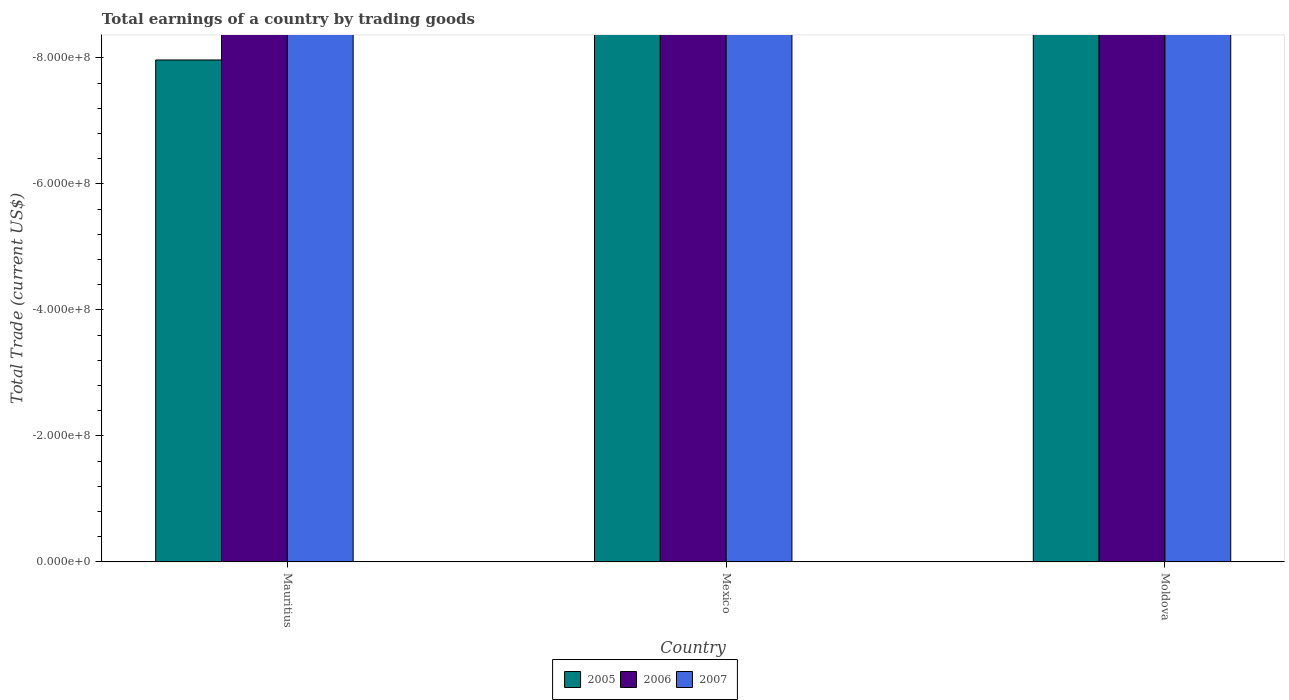Are the number of bars per tick equal to the number of legend labels?
Offer a terse response. No. Are the number of bars on each tick of the X-axis equal?
Make the answer very short. Yes. What is the label of the 3rd group of bars from the left?
Offer a terse response. Moldova. What is the total earnings in 2007 in Moldova?
Give a very brief answer. 0. Across all countries, what is the minimum total earnings in 2007?
Make the answer very short. 0. In how many countries, is the total earnings in 2007 greater than -320000000 US$?
Your response must be concise. 0. In how many countries, is the total earnings in 2005 greater than the average total earnings in 2005 taken over all countries?
Provide a succinct answer. 0. Is it the case that in every country, the sum of the total earnings in 2005 and total earnings in 2006 is greater than the total earnings in 2007?
Ensure brevity in your answer.  No. Are all the bars in the graph horizontal?
Provide a succinct answer. No. What is the difference between two consecutive major ticks on the Y-axis?
Provide a succinct answer. 2.00e+08. Are the values on the major ticks of Y-axis written in scientific E-notation?
Ensure brevity in your answer.  Yes. Does the graph contain any zero values?
Provide a short and direct response. Yes. Where does the legend appear in the graph?
Offer a very short reply. Bottom center. How many legend labels are there?
Your answer should be compact. 3. How are the legend labels stacked?
Your answer should be very brief. Horizontal. What is the title of the graph?
Ensure brevity in your answer.  Total earnings of a country by trading goods. Does "1962" appear as one of the legend labels in the graph?
Offer a terse response. No. What is the label or title of the X-axis?
Your answer should be compact. Country. What is the label or title of the Y-axis?
Make the answer very short. Total Trade (current US$). What is the Total Trade (current US$) of 2006 in Mauritius?
Offer a terse response. 0. What is the Total Trade (current US$) of 2005 in Mexico?
Your answer should be compact. 0. What is the Total Trade (current US$) of 2007 in Mexico?
Provide a succinct answer. 0. What is the total Total Trade (current US$) of 2005 in the graph?
Keep it short and to the point. 0. What is the total Total Trade (current US$) in 2006 in the graph?
Keep it short and to the point. 0. What is the average Total Trade (current US$) in 2005 per country?
Give a very brief answer. 0. 